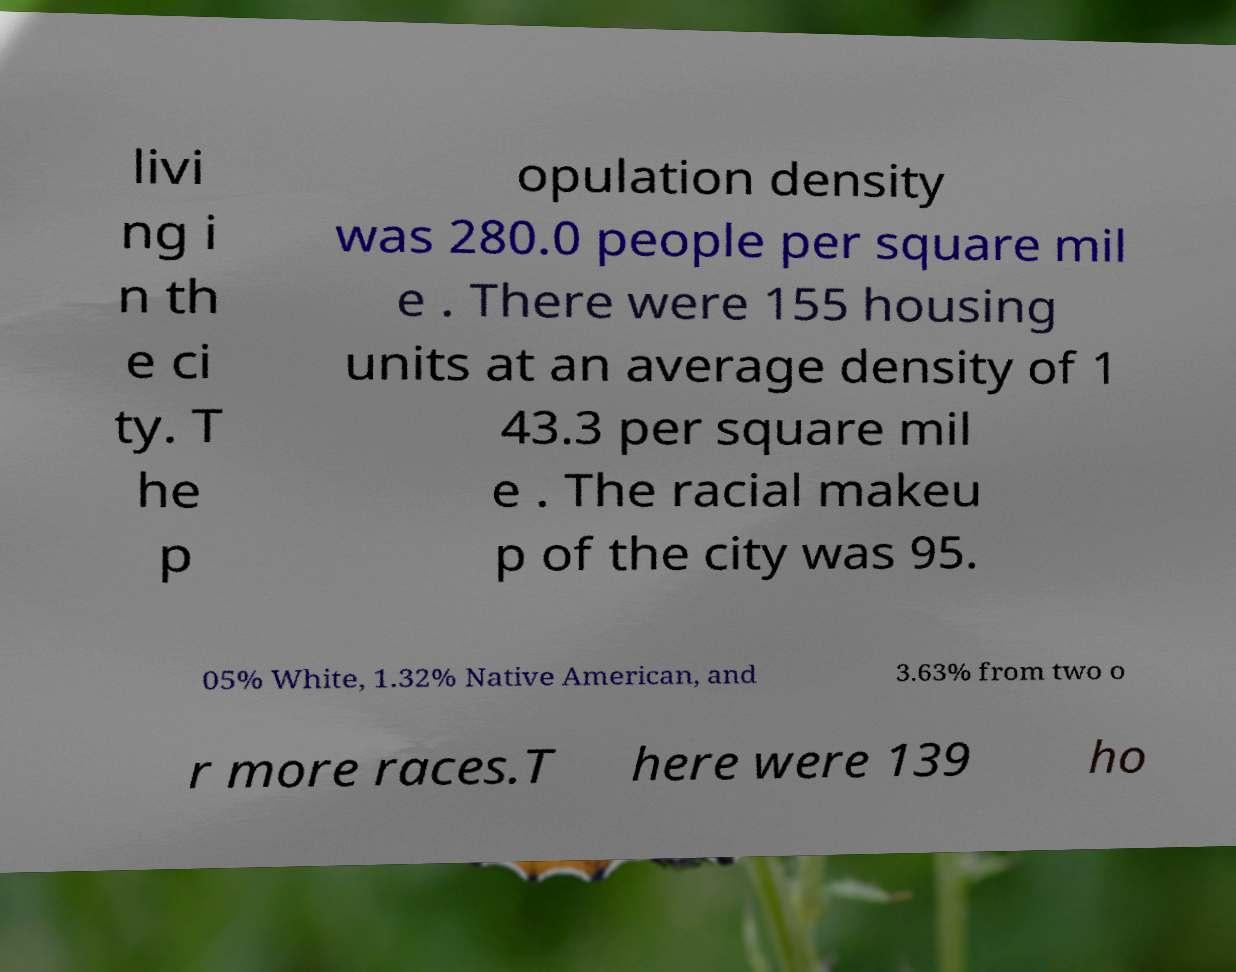I need the written content from this picture converted into text. Can you do that? livi ng i n th e ci ty. T he p opulation density was 280.0 people per square mil e . There were 155 housing units at an average density of 1 43.3 per square mil e . The racial makeu p of the city was 95. 05% White, 1.32% Native American, and 3.63% from two o r more races.T here were 139 ho 